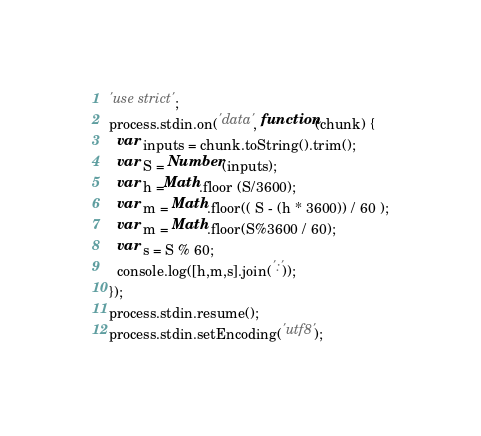<code> <loc_0><loc_0><loc_500><loc_500><_JavaScript_>'use strict';
process.stdin.on('data', function(chunk) {
  var inputs = chunk.toString().trim();
  var S = Number(inputs);
  var h =Math.floor (S/3600);
  var m = Math.floor(( S - (h * 3600)) / 60 );
  var m = Math.floor(S%3600 / 60);
  var s = S % 60;
  console.log([h,m,s].join(':'));
});
process.stdin.resume();
process.stdin.setEncoding('utf8');</code> 